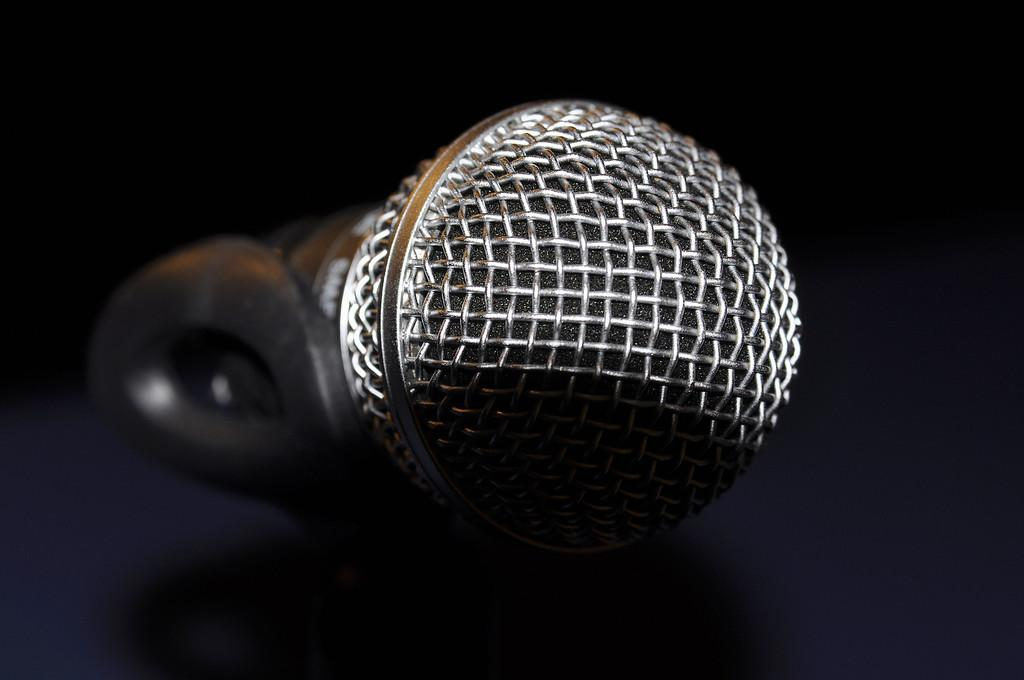What is the main object in the image? There is a sound mike in the image. Can you describe the appearance of the sound mike? The sound mike is silver and black in color. What can be observed about the background of the image? The background of the image appears dark. How many cherries are on the button of the sweater in the image? There is no sweater or button with cherries present in the image. 